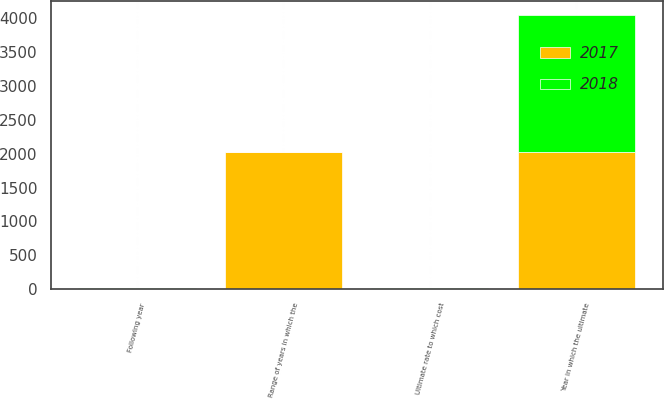<chart> <loc_0><loc_0><loc_500><loc_500><stacked_bar_chart><ecel><fcel>Following year<fcel>Ultimate rate to which cost<fcel>Year in which the ultimate<fcel>Range of years in which the<nl><fcel>2017<fcel>7<fcel>5<fcel>2027<fcel>2019<nl><fcel>2018<fcel>6.5<fcel>5<fcel>2023<fcel>7<nl></chart> 